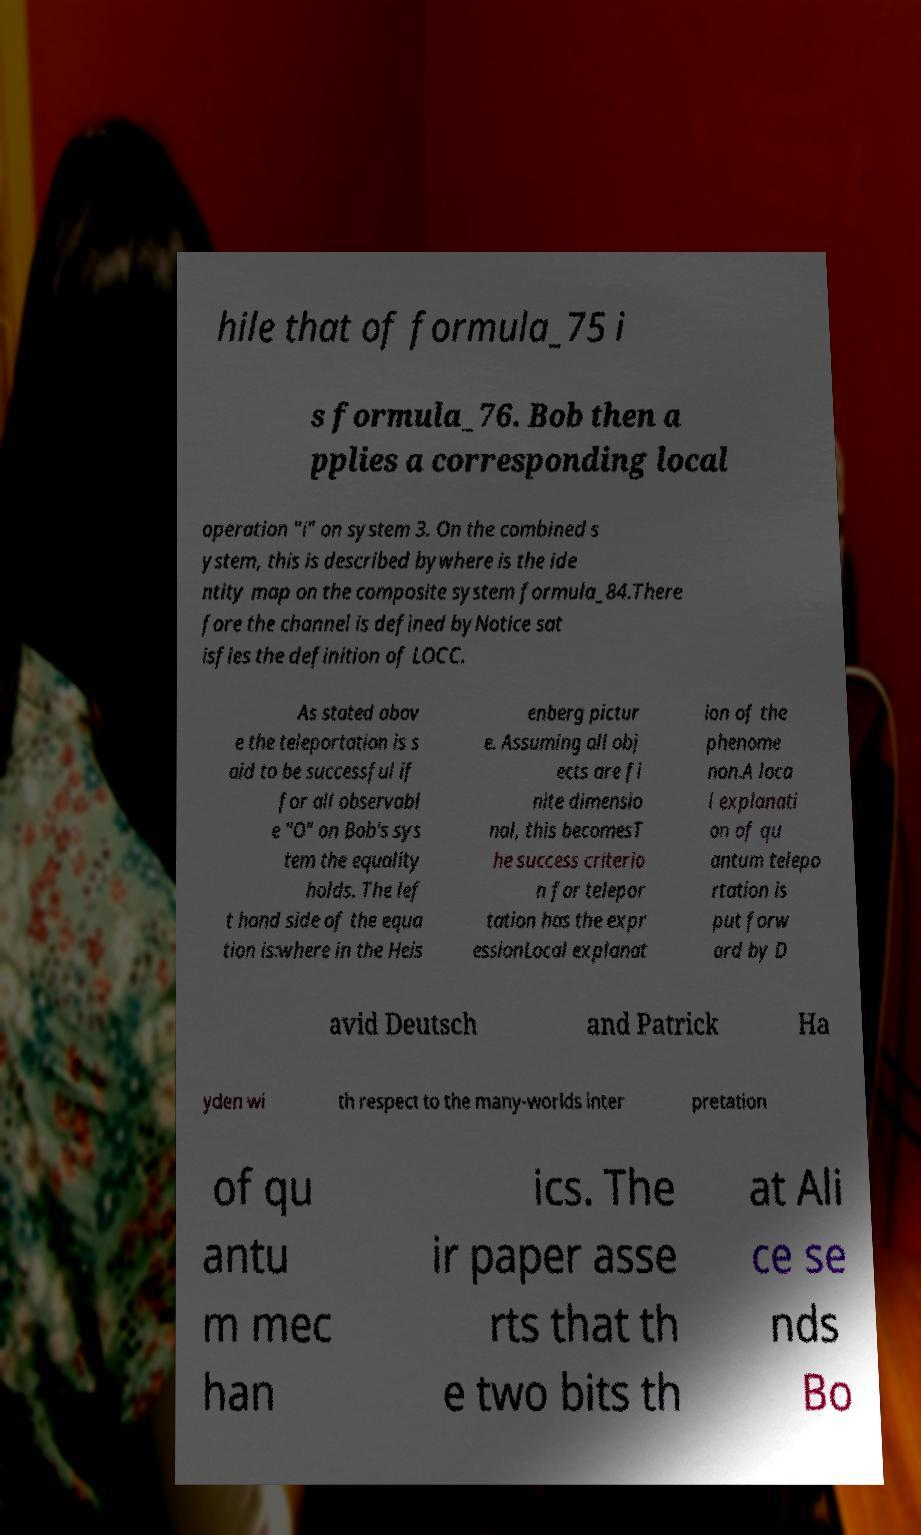Please read and relay the text visible in this image. What does it say? hile that of formula_75 i s formula_76. Bob then a pplies a corresponding local operation "i" on system 3. On the combined s ystem, this is described bywhere is the ide ntity map on the composite system formula_84.There fore the channel is defined byNotice sat isfies the definition of LOCC. As stated abov e the teleportation is s aid to be successful if for all observabl e "O" on Bob's sys tem the equality holds. The lef t hand side of the equa tion is:where in the Heis enberg pictur e. Assuming all obj ects are fi nite dimensio nal, this becomesT he success criterio n for telepor tation has the expr essionLocal explanat ion of the phenome non.A loca l explanati on of qu antum telepo rtation is put forw ard by D avid Deutsch and Patrick Ha yden wi th respect to the many-worlds inter pretation of qu antu m mec han ics. The ir paper asse rts that th e two bits th at Ali ce se nds Bo 